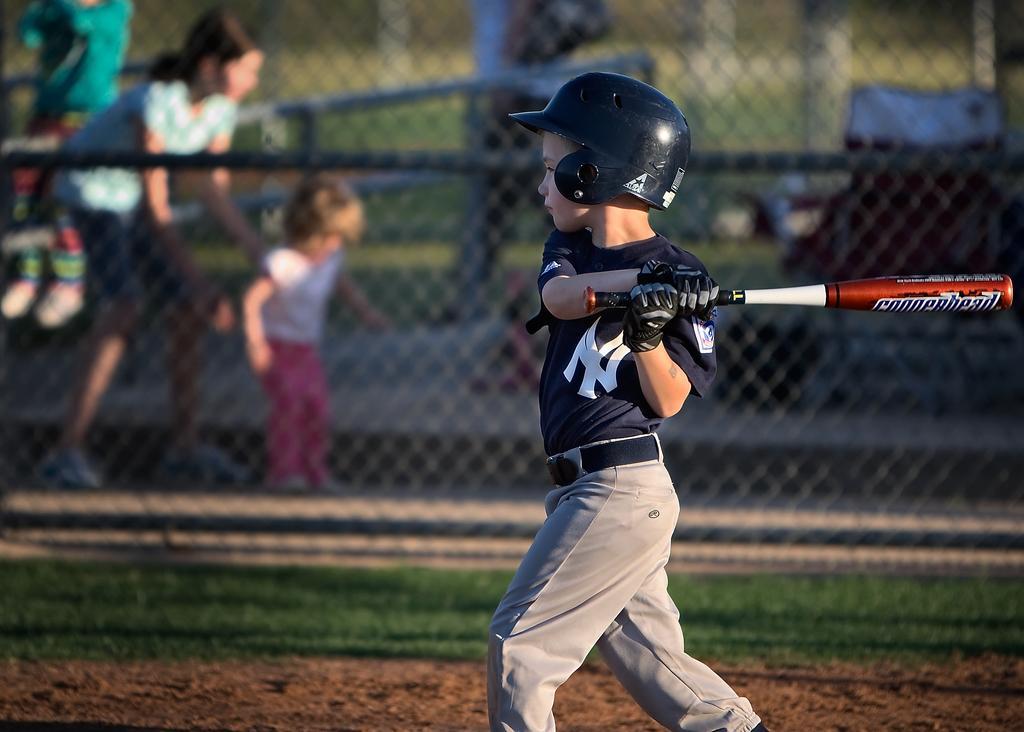Can you describe this image briefly? This is a playing ground. Here I can see a boy holding bat in the hands, wearing a helmet and standing facing towards the left side. In the background there is a net. Behind the net there is women, a baby and a person are standing. On the ground, I can see the grass. 